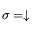<formula> <loc_0><loc_0><loc_500><loc_500>\sigma = \downarrow</formula> 